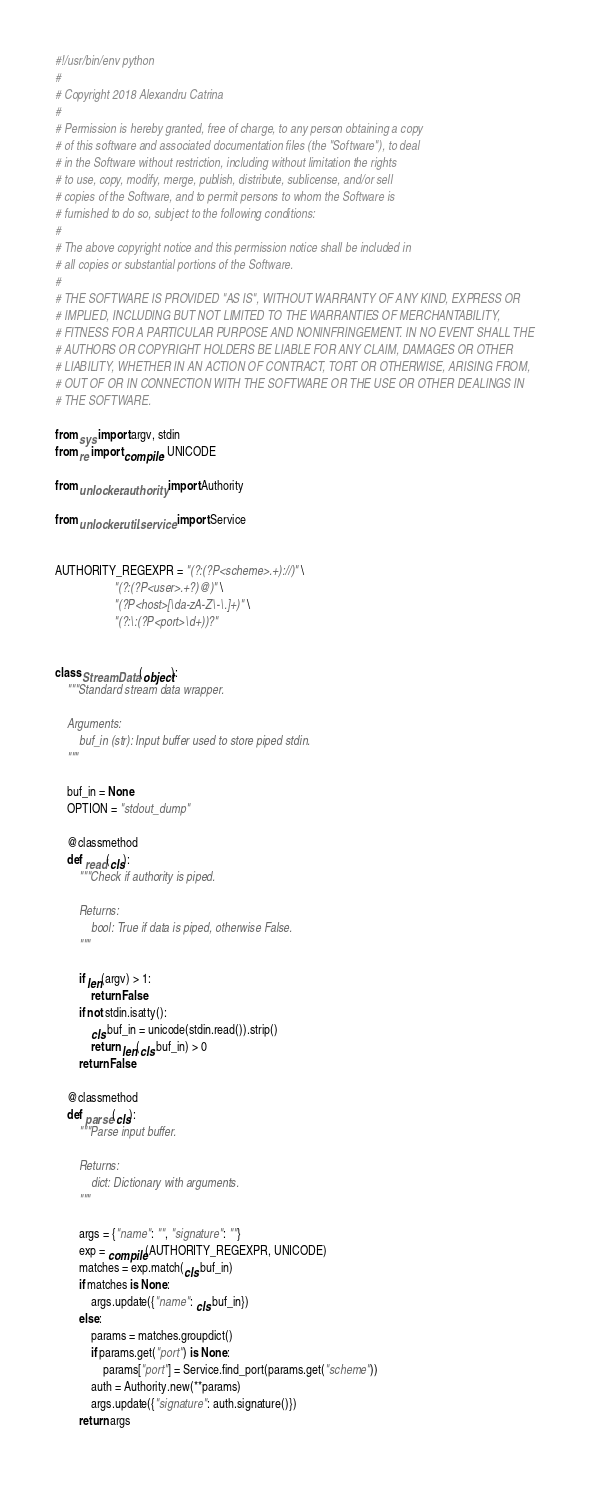Convert code to text. <code><loc_0><loc_0><loc_500><loc_500><_Python_>#!/usr/bin/env python
#
# Copyright 2018 Alexandru Catrina
#
# Permission is hereby granted, free of charge, to any person obtaining a copy
# of this software and associated documentation files (the "Software"), to deal
# in the Software without restriction, including without limitation the rights
# to use, copy, modify, merge, publish, distribute, sublicense, and/or sell
# copies of the Software, and to permit persons to whom the Software is
# furnished to do so, subject to the following conditions:
#
# The above copyright notice and this permission notice shall be included in
# all copies or substantial portions of the Software.
#
# THE SOFTWARE IS PROVIDED "AS IS", WITHOUT WARRANTY OF ANY KIND, EXPRESS OR
# IMPLIED, INCLUDING BUT NOT LIMITED TO THE WARRANTIES OF MERCHANTABILITY,
# FITNESS FOR A PARTICULAR PURPOSE AND NONINFRINGEMENT. IN NO EVENT SHALL THE
# AUTHORS OR COPYRIGHT HOLDERS BE LIABLE FOR ANY CLAIM, DAMAGES OR OTHER
# LIABILITY, WHETHER IN AN ACTION OF CONTRACT, TORT OR OTHERWISE, ARISING FROM,
# OUT OF OR IN CONNECTION WITH THE SOFTWARE OR THE USE OR OTHER DEALINGS IN
# THE SOFTWARE.

from sys import argv, stdin
from re import compile, UNICODE

from unlocker.authority import Authority

from unlocker.util.service import Service


AUTHORITY_REGEXPR = "(?:(?P<scheme>.+)://)" \
                    "(?:(?P<user>.+?)@)" \
                    "(?P<host>[\da-zA-Z\-\.]+)" \
                    "(?:\:(?P<port>\d+))?"


class StreamData(object):
    """Standard stream data wrapper.

    Arguments:
        buf_in (str): Input buffer used to store piped stdin.
    """

    buf_in = None
    OPTION = "stdout_dump"

    @classmethod
    def read(cls):
        """Check if authority is piped.

        Returns:
            bool: True if data is piped, otherwise False.
        """

        if len(argv) > 1:
            return False
        if not stdin.isatty():
            cls.buf_in = unicode(stdin.read()).strip()
            return len(cls.buf_in) > 0
        return False

    @classmethod
    def parse(cls):
        """Parse input buffer.

        Returns:
            dict: Dictionary with arguments.
        """

        args = {"name": "", "signature": ""}
        exp = compile(AUTHORITY_REGEXPR, UNICODE)
        matches = exp.match(cls.buf_in)
        if matches is None:
            args.update({"name": cls.buf_in})
        else:
            params = matches.groupdict()
            if params.get("port") is None:
                params["port"] = Service.find_port(params.get("scheme"))
            auth = Authority.new(**params)
            args.update({"signature": auth.signature()})
        return args
</code> 